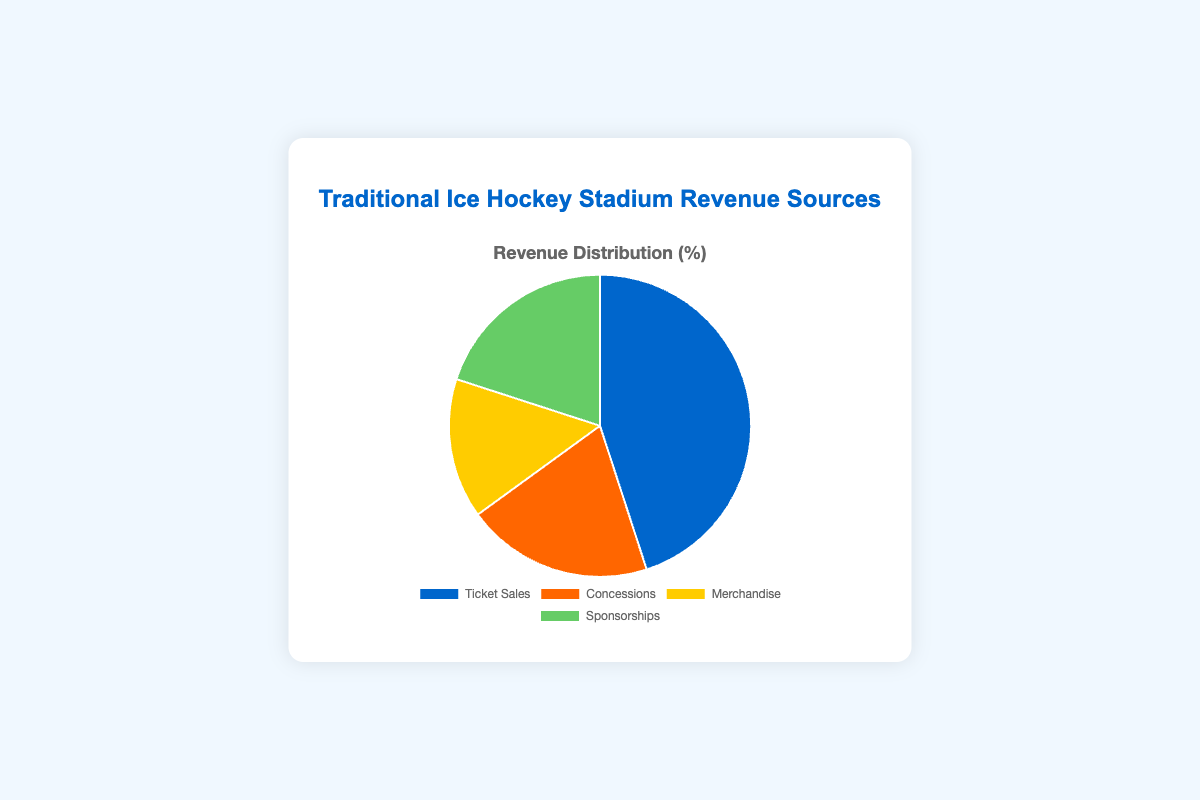What percentage of revenue comes from Ticket Sales? From the pie chart, we can directly see that Ticket Sales contribute 45% to the total revenue.
Answer: 45% Which revenue source contributes the least? By comparing the slices, Merchandise has the smallest slice, indicating it contributes the least.
Answer: Merchandise How does the combined percentage of Concessions and Sponsorships compare to Ticket Sales? Concessions and Sponsorships together make up 20% + 20% = 40%, whereas Ticket Sales account for 45%. So they combined are slightly less than Ticket Sales.
Answer: Less What is the difference in revenue contribution between Ticket Sales and Merchandise? Ticket Sales contribute 45% and Merchandise contributes 15%, so the difference is 45% - 15% = 30%.
Answer: 30% What percentage of revenue comes from sources other than Ticket Sales? The other sources are Concessions (20%), Merchandise (15%), and Sponsorships (20%). Summing these percentages gives 20% + 15% + 20% = 55%.
Answer: 55% What is the ratio of revenue from Ticket Sales to Concessions? Ticket Sales percentage is 45% and Concessions is 20%. The ratio is 45:20, which simplifies to 9:4.
Answer: 9:4 Which revenue source has the same contribution as Sponsorships? According to the pie chart, Concessions and Sponsorships both contribute 20% to the total revenue.
Answer: Concessions If Sponsorships increased by 5%, what would be the new percentage contribution of Sponsorships? Currently, Sponsorships contribute 20%. Adding 5% to this, the new contribution would be 20% + 5% = 25%.
Answer: 25% What colors are used to represent Ticket Sales and Merchandise in the chart? The pie chart uses blue for Ticket Sales and yellow for Merchandise.
Answer: Blue, Yellow 